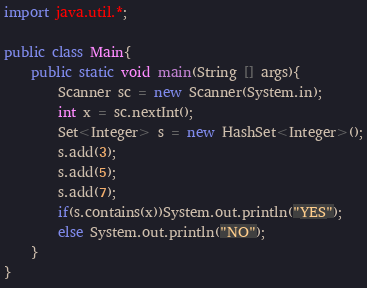Convert code to text. <code><loc_0><loc_0><loc_500><loc_500><_Java_>import java.util.*;

public class Main{
    public static void main(String [] args){
        Scanner sc = new Scanner(System.in);
        int x = sc.nextInt();
        Set<Integer> s = new HashSet<Integer>();
        s.add(3);
        s.add(5);
        s.add(7);
        if(s.contains(x))System.out.println("YES");
        else System.out.println("NO");
    }
}</code> 